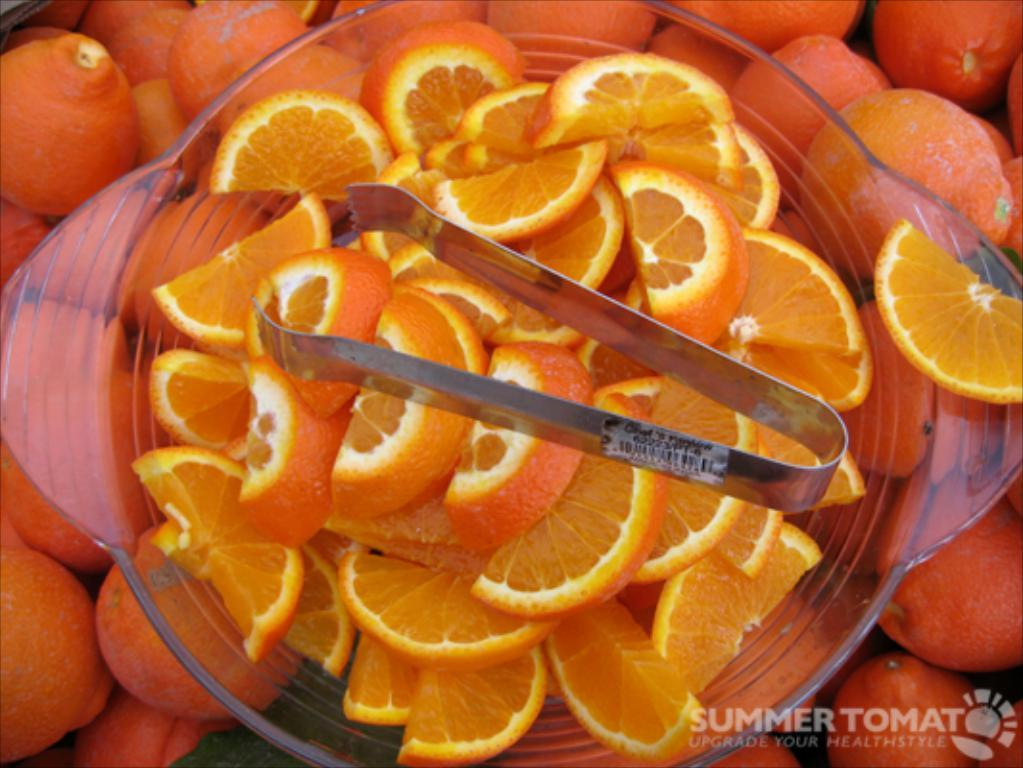What type of fruit is present in the image? There are orange slices in the image. How are the orange slices arranged or held in the image? There is a holder in the bowl with oranges. Can you describe any additional elements in the image? There is a watermark in the bottom corner on the right side of the image. What type of icicle can be seen hanging from the holder in the image? There is no icicle present in the image; it features orange slices in a holder. Can you tell me how the son starts the game in the image? There is no son or game present in the image; it only shows orange slices in a holder with a watermark. 